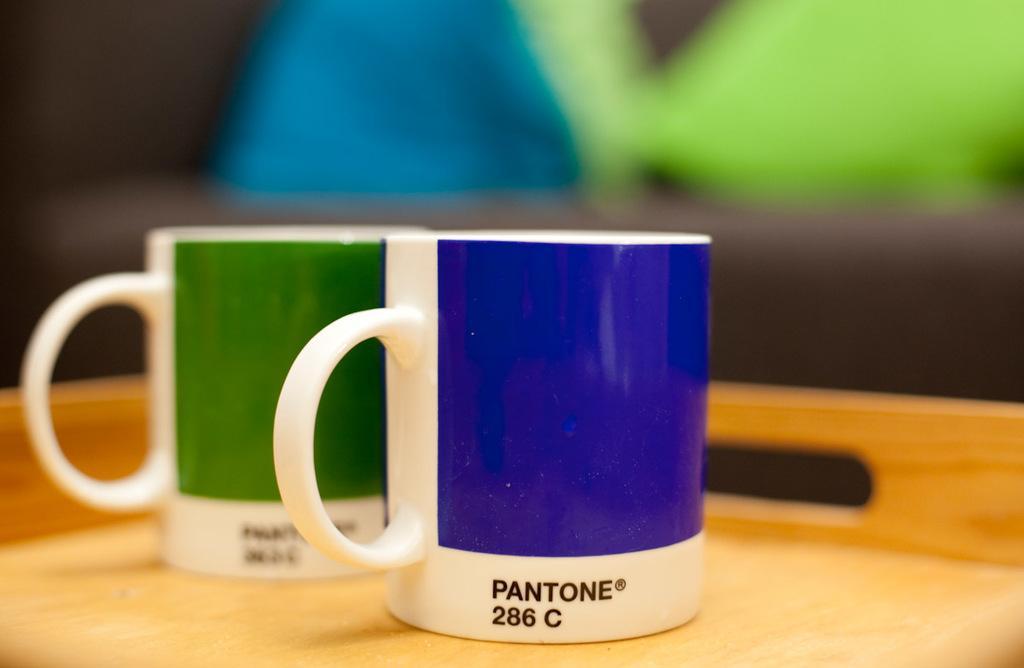Could you give a brief overview of what you see in this image? In this image we can see two coffee mugs placed on a tray. 